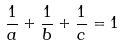<formula> <loc_0><loc_0><loc_500><loc_500>\frac { 1 } { a } + \frac { 1 } { b } + \frac { 1 } { c } = 1</formula> 